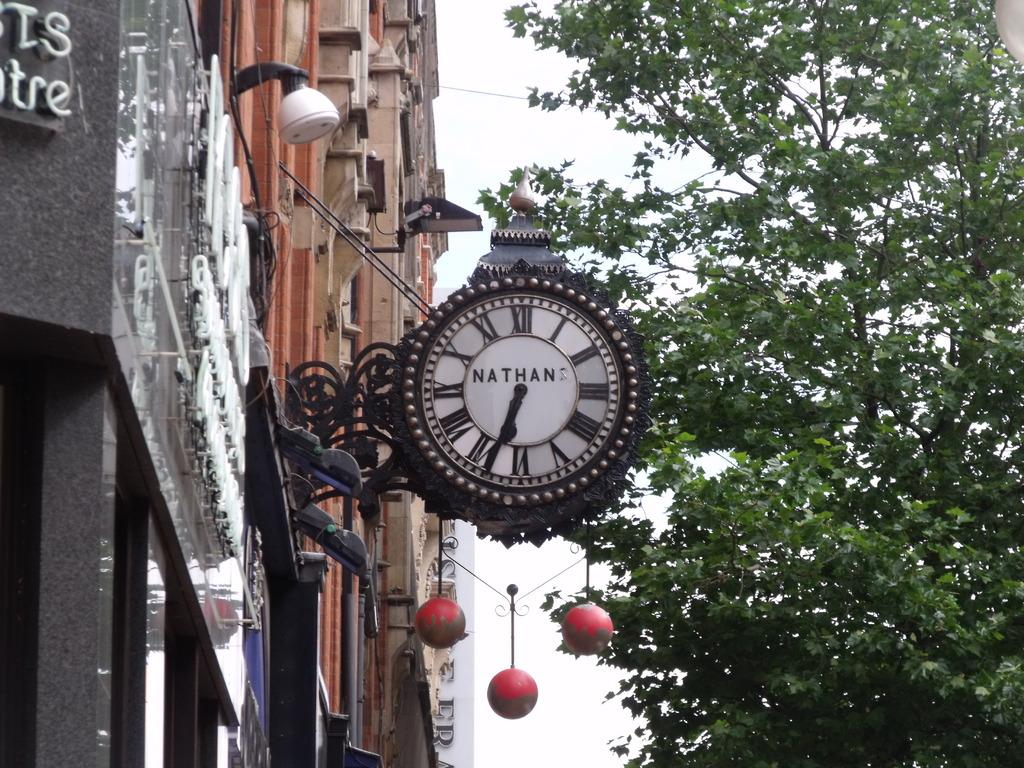Provide a one-sentence caption for the provided image. A clock made by Nathan sticks out from a pawnbrokers and tells us it is 6:35. 